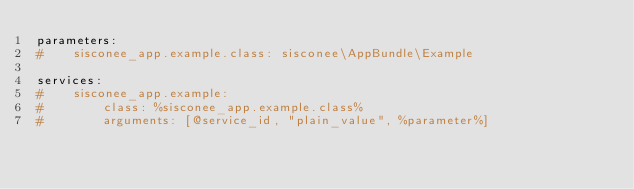<code> <loc_0><loc_0><loc_500><loc_500><_YAML_>parameters:
#    sisconee_app.example.class: sisconee\AppBundle\Example

services:
#    sisconee_app.example:
#        class: %sisconee_app.example.class%
#        arguments: [@service_id, "plain_value", %parameter%]
</code> 